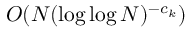Convert formula to latex. <formula><loc_0><loc_0><loc_500><loc_500>O ( N ( \log \log N ) ^ { - c _ { k } } )</formula> 